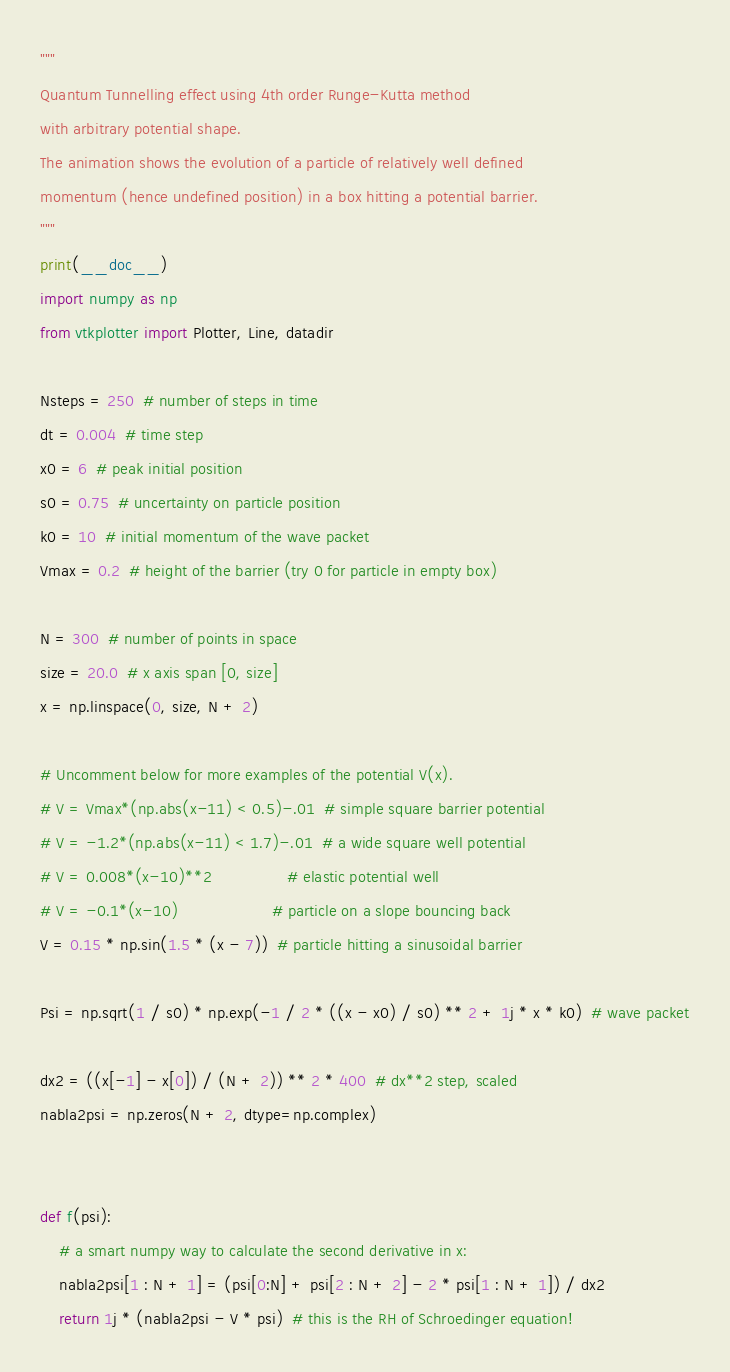<code> <loc_0><loc_0><loc_500><loc_500><_Python_>"""
Quantum Tunnelling effect using 4th order Runge-Kutta method
with arbitrary potential shape.
The animation shows the evolution of a particle of relatively well defined
momentum (hence undefined position) in a box hitting a potential barrier.
"""
print(__doc__)
import numpy as np
from vtkplotter import Plotter, Line, datadir

Nsteps = 250  # number of steps in time
dt = 0.004  # time step
x0 = 6  # peak initial position
s0 = 0.75  # uncertainty on particle position
k0 = 10  # initial momentum of the wave packet
Vmax = 0.2  # height of the barrier (try 0 for particle in empty box)

N = 300  # number of points in space
size = 20.0  # x axis span [0, size]
x = np.linspace(0, size, N + 2)

# Uncomment below for more examples of the potential V(x).
# V = Vmax*(np.abs(x-11) < 0.5)-.01  # simple square barrier potential
# V = -1.2*(np.abs(x-11) < 1.7)-.01  # a wide square well potential
# V = 0.008*(x-10)**2                # elastic potential well
# V = -0.1*(x-10)                    # particle on a slope bouncing back
V = 0.15 * np.sin(1.5 * (x - 7))  # particle hitting a sinusoidal barrier

Psi = np.sqrt(1 / s0) * np.exp(-1 / 2 * ((x - x0) / s0) ** 2 + 1j * x * k0)  # wave packet

dx2 = ((x[-1] - x[0]) / (N + 2)) ** 2 * 400  # dx**2 step, scaled
nabla2psi = np.zeros(N + 2, dtype=np.complex)


def f(psi):
    # a smart numpy way to calculate the second derivative in x:
    nabla2psi[1 : N + 1] = (psi[0:N] + psi[2 : N + 2] - 2 * psi[1 : N + 1]) / dx2
    return 1j * (nabla2psi - V * psi)  # this is the RH of Schroedinger equation!

</code> 